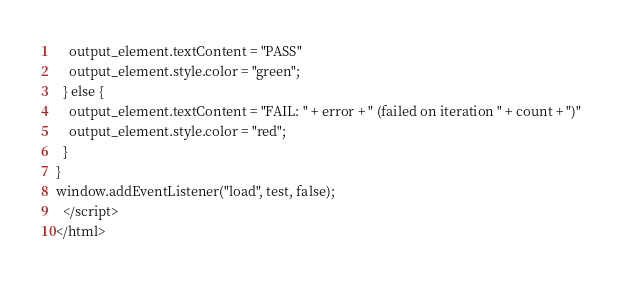Convert code to text. <code><loc_0><loc_0><loc_500><loc_500><_HTML_>    output_element.textContent = "PASS"
    output_element.style.color = "green";
  } else {
    output_element.textContent = "FAIL: " + error + " (failed on iteration " + count + ")"
    output_element.style.color = "red";
  }
}
window.addEventListener("load", test, false);
  </script>
</html></code> 